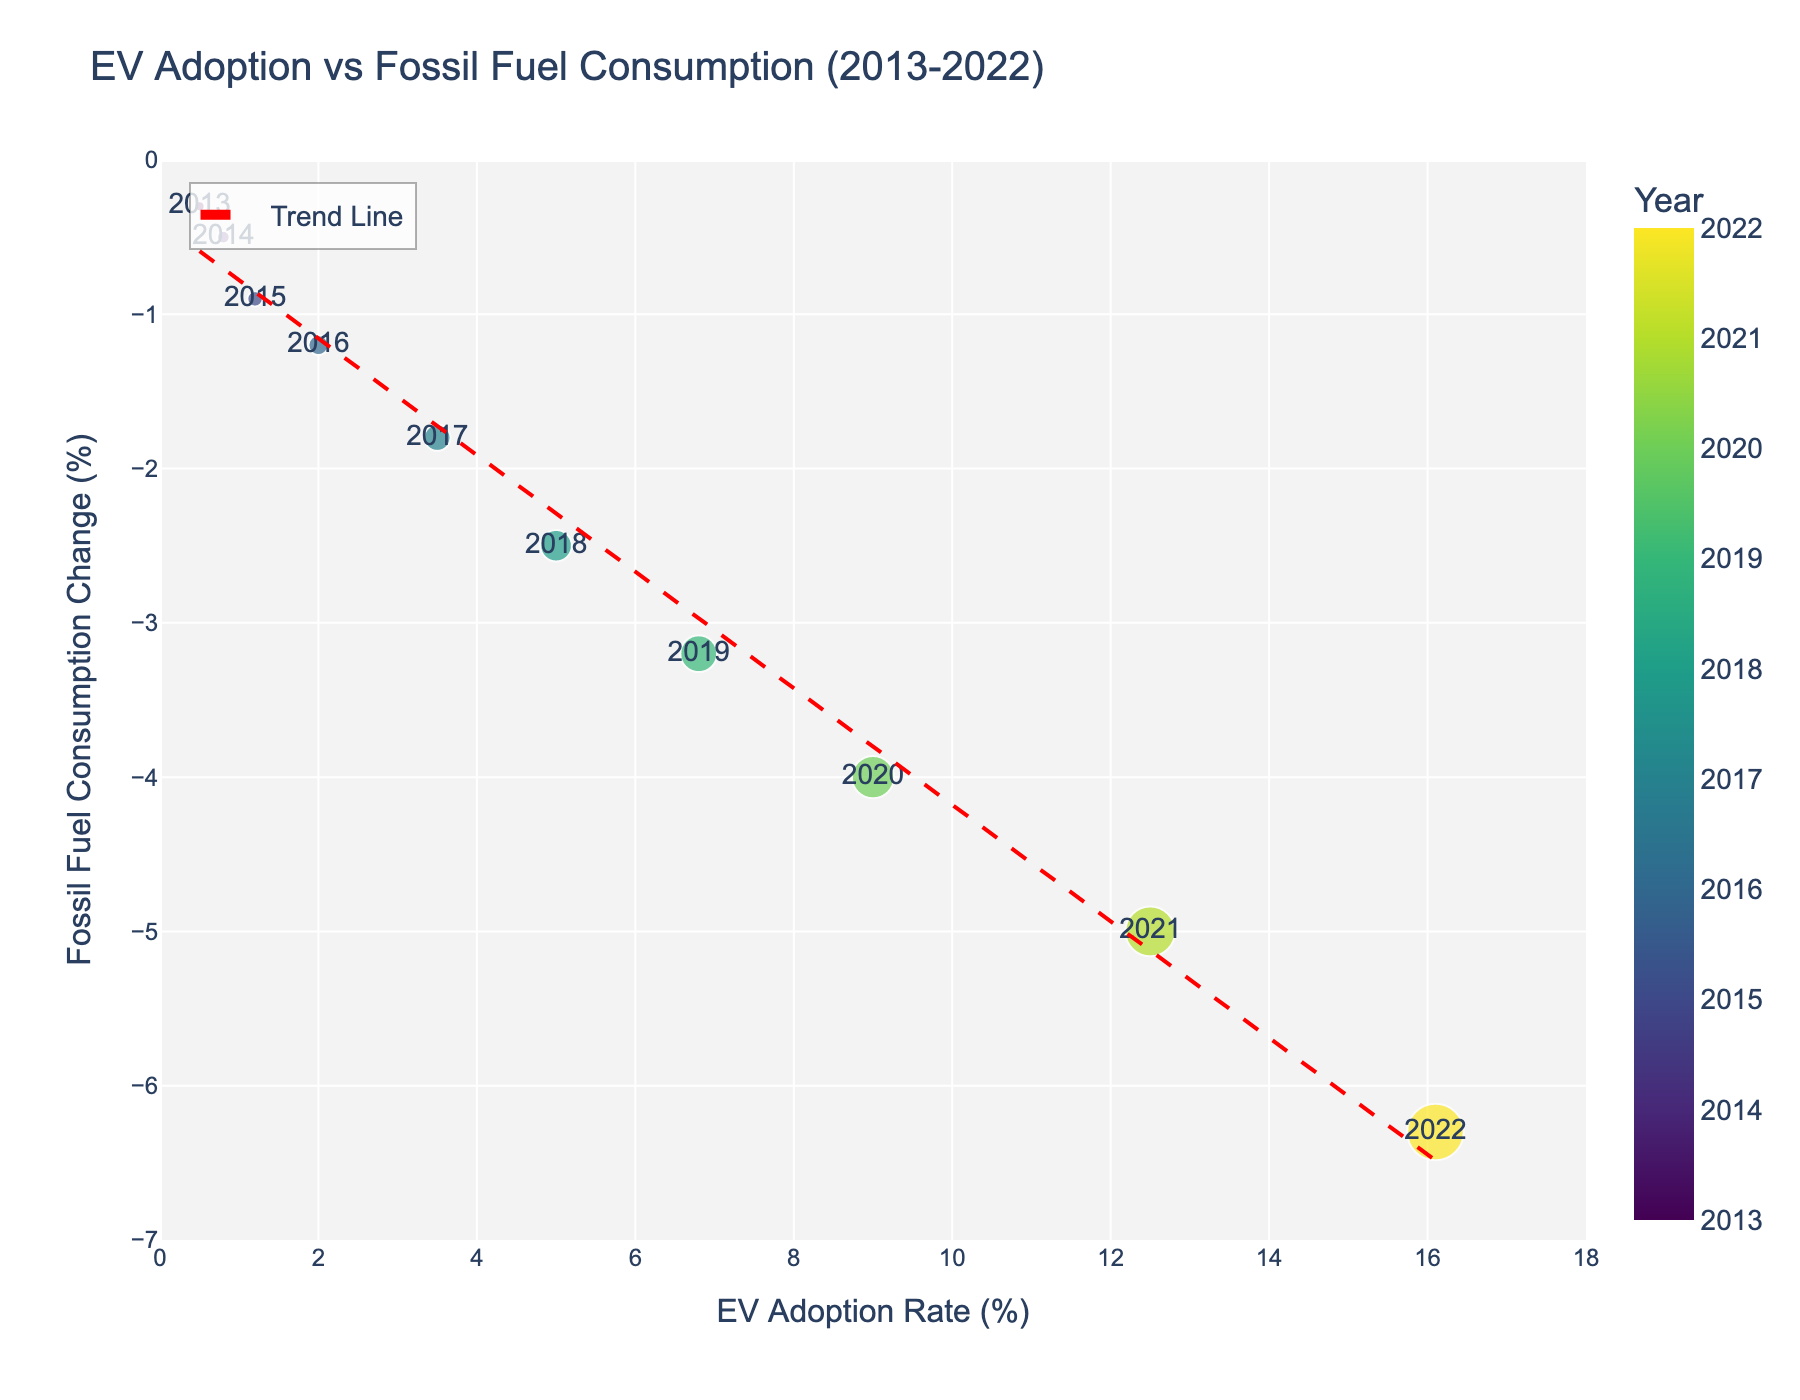What is the title of the figure? The title of the figure is displayed prominently at the top center. It reads "EV Adoption vs Fossil Fuel Consumption (2013-2022)"
Answer: EV Adoption vs Fossil Fuel Consumption (2013-2022) How many data points are shown in the figure? Each data point corresponds to a year from 2013 to 2022. Count the number of distinct points or markers present in the figure. There are 10 years shown.
Answer: 10 What color represents the trend line in the scatter plot? The trend line is shown in a different color from the data points for clarity. It is red in color, as indicated by the line joining the data points.
Answer: Red What is the range of the X-axis (EV Adoption Rate)? The X-axis represents the EV Adoption Rate (%). The range can be determined by looking at the minimum and maximum values shown in the axis. It ranges from 0 to 18.
Answer: 0 to 18 What is the EV Adoption Rate in 2020? Each data point is labeled with the year, and by finding the point labeled 2020, we can see its corresponding EV Adoption Rate. The EV Adoption Rate for 2020 is 9.0%.
Answer: 9.0% In which year did the Fossil Fuel Consumption Change reach -5.0%? By checking the labels on the points, we find the year where the Y-axis value reaches -5.0%. It corresponds to the year 2021.
Answer: 2021 What was the rate of change in Fossil Fuel Consumption from 2018 to 2020? First, find the Y-axis values for the years 2018 and 2020, which are -2.5% and -4.0% respectively. Subtract the 2018 value from the 2020 value to determine the change. The change is -4.0% - (-2.5%) = -1.5%.
Answer: -1.5% How does the trend line suggest the relationship between EV Adoption and Fossil Fuel Consumption? The trend line, added to the scatter plot, visually shows a negative correlation. As EV Adoption Rate (%) increases, Fossil Fuel Consumption Change (%) decreases, indicated by the downward slope of the trend line.
Answer: Negative correlation Which year saw the most significant increase in EV Adoption Rate? By visually inspecting the year-to-year increments in the size of the bubbles (which represent EV Adoption Rate), we see the most significant jump occurs between 2020 and 2021. The EV Adoption Rate increased from 9.0% to 12.5%, a difference of 3.5%.
Answer: 2020 to 2021 Compare the Fossil Fuel Consumption Change in 2015 to that in 2018. What is the difference? Find the Y-axis values for the years 2015 and 2018, which are -0.9% and -2.5% respectively. Subtract the 2015 value from the 2018 value to find the difference. The difference is -2.5% - (-0.9%) = -1.6%.
Answer: -1.6% 